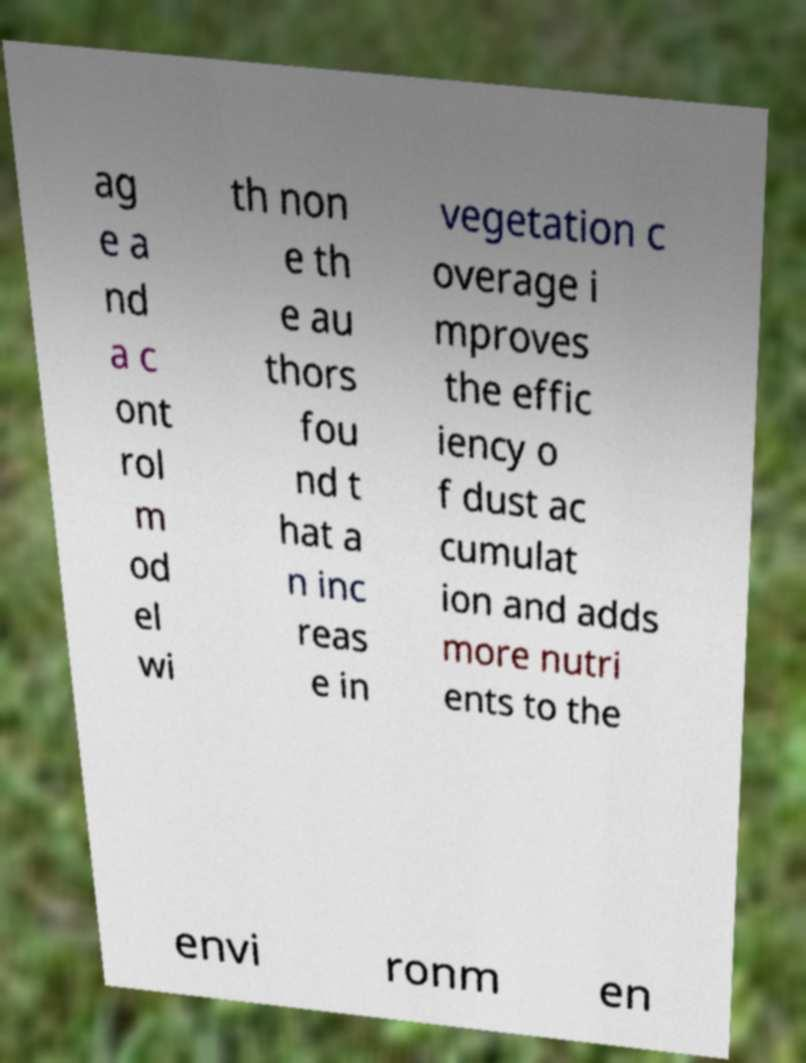Could you extract and type out the text from this image? ag e a nd a c ont rol m od el wi th non e th e au thors fou nd t hat a n inc reas e in vegetation c overage i mproves the effic iency o f dust ac cumulat ion and adds more nutri ents to the envi ronm en 